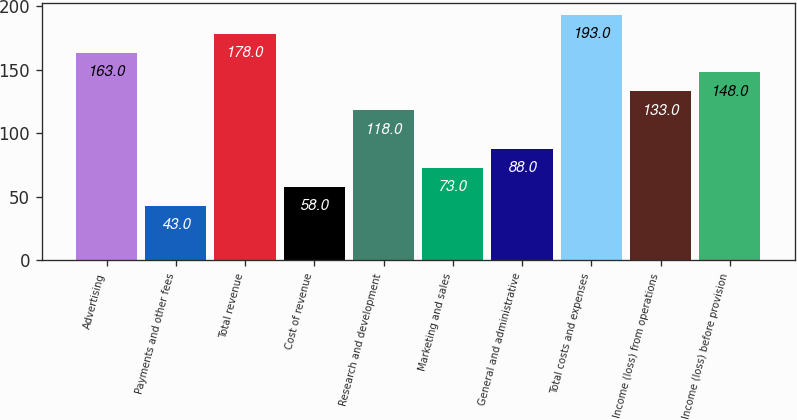<chart> <loc_0><loc_0><loc_500><loc_500><bar_chart><fcel>Advertising<fcel>Payments and other fees<fcel>Total revenue<fcel>Cost of revenue<fcel>Research and development<fcel>Marketing and sales<fcel>General and administrative<fcel>Total costs and expenses<fcel>Income (loss) from operations<fcel>Income (loss) before provision<nl><fcel>163<fcel>43<fcel>178<fcel>58<fcel>118<fcel>73<fcel>88<fcel>193<fcel>133<fcel>148<nl></chart> 